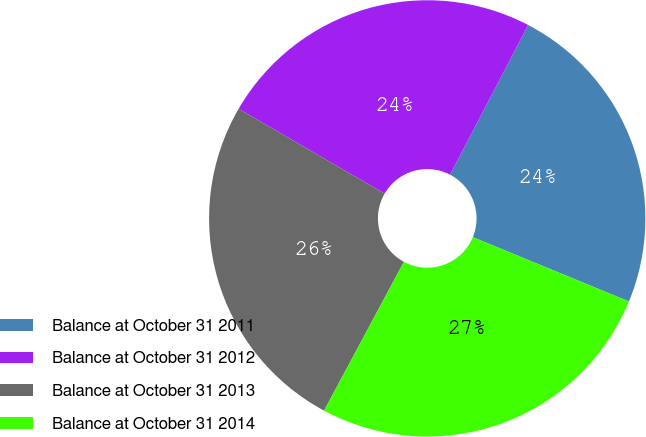<chart> <loc_0><loc_0><loc_500><loc_500><pie_chart><fcel>Balance at October 31 2011<fcel>Balance at October 31 2012<fcel>Balance at October 31 2013<fcel>Balance at October 31 2014<nl><fcel>23.56%<fcel>24.28%<fcel>25.53%<fcel>26.62%<nl></chart> 